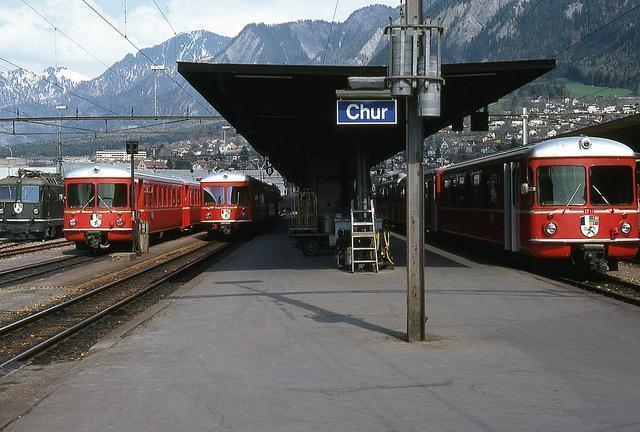What mountains are these?
Pick the right solution, then justify: 'Answer: answer
Rationale: rationale.'
Options: Appalachian, rocky mountains, pyrenees, alps. Answer: alps.
Rationale: The mountains are the alps. 